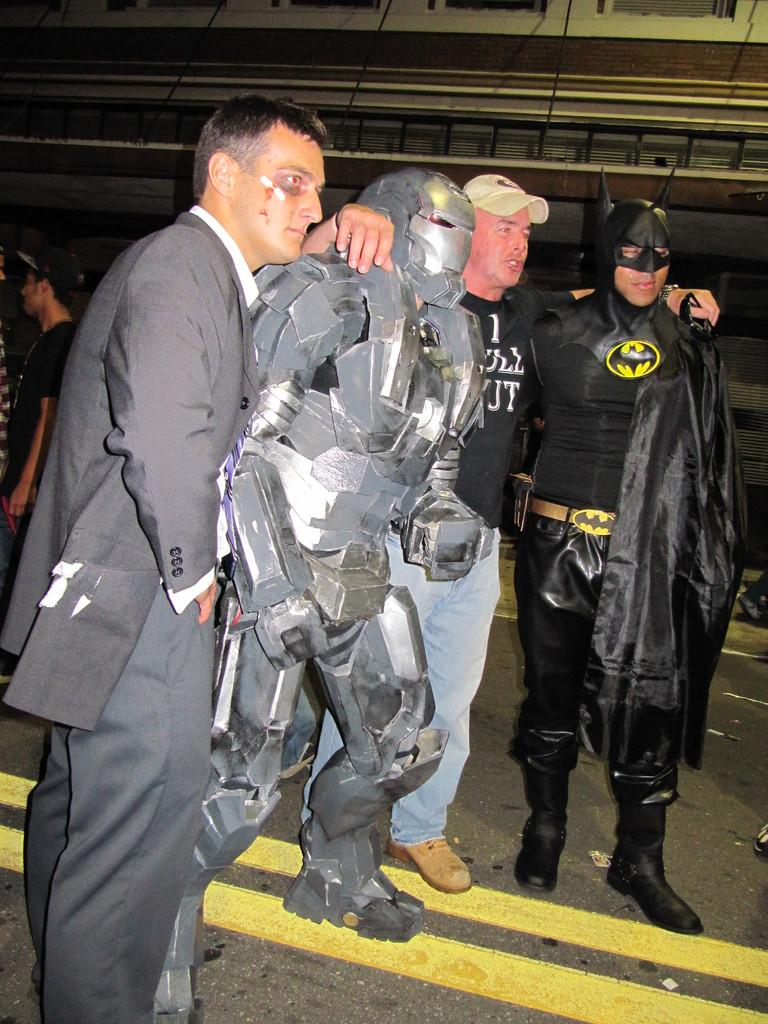How many people are in the image? There are two persons in the image. What costumes are the persons wearing? One person is dressed as Batman, and the other person is dressed as Iron Man. What are the two persons doing in the image? The two persons are posing for the camera. Are the two persons in the image kissing? There is no indication of a kiss in the image. The two persons are dressed as Batman and Iron Man, and they are posing for the camera. 